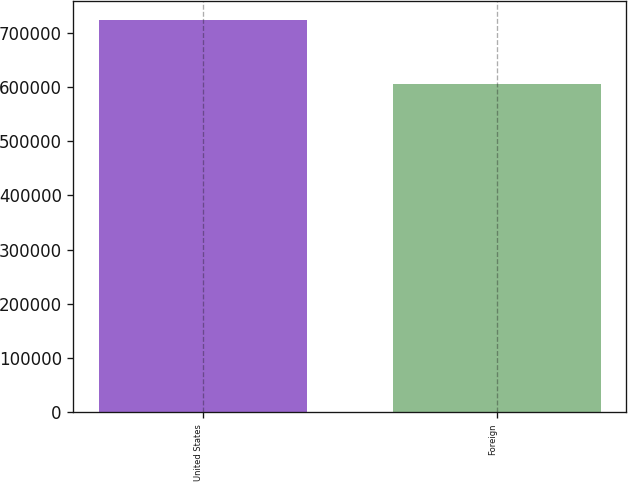Convert chart. <chart><loc_0><loc_0><loc_500><loc_500><bar_chart><fcel>United States<fcel>Foreign<nl><fcel>722925<fcel>605716<nl></chart> 